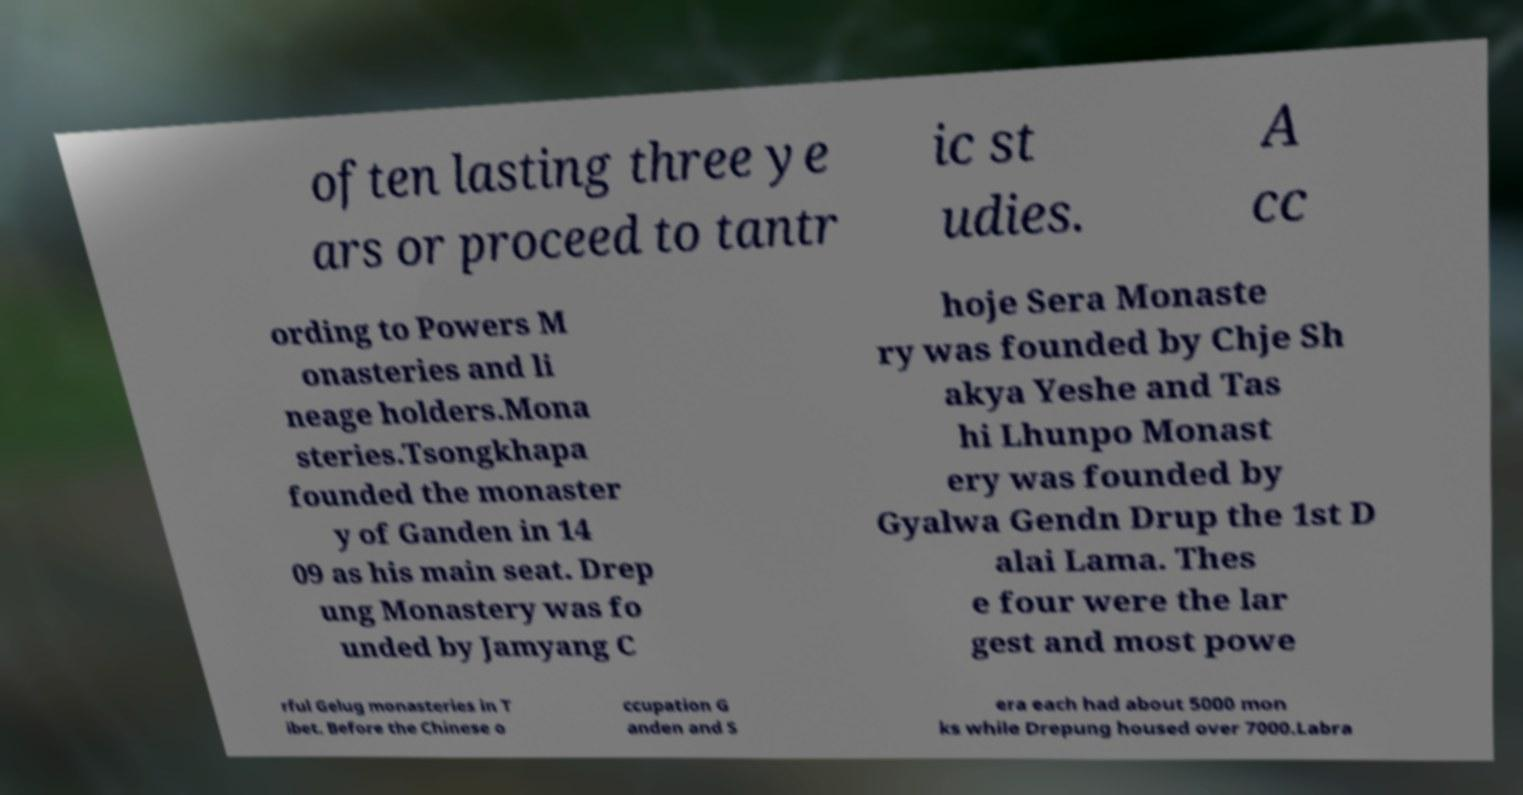For documentation purposes, I need the text within this image transcribed. Could you provide that? often lasting three ye ars or proceed to tantr ic st udies. A cc ording to Powers M onasteries and li neage holders.Mona steries.Tsongkhapa founded the monaster y of Ganden in 14 09 as his main seat. Drep ung Monastery was fo unded by Jamyang C hoje Sera Monaste ry was founded by Chje Sh akya Yeshe and Tas hi Lhunpo Monast ery was founded by Gyalwa Gendn Drup the 1st D alai Lama. Thes e four were the lar gest and most powe rful Gelug monasteries in T ibet. Before the Chinese o ccupation G anden and S era each had about 5000 mon ks while Drepung housed over 7000.Labra 